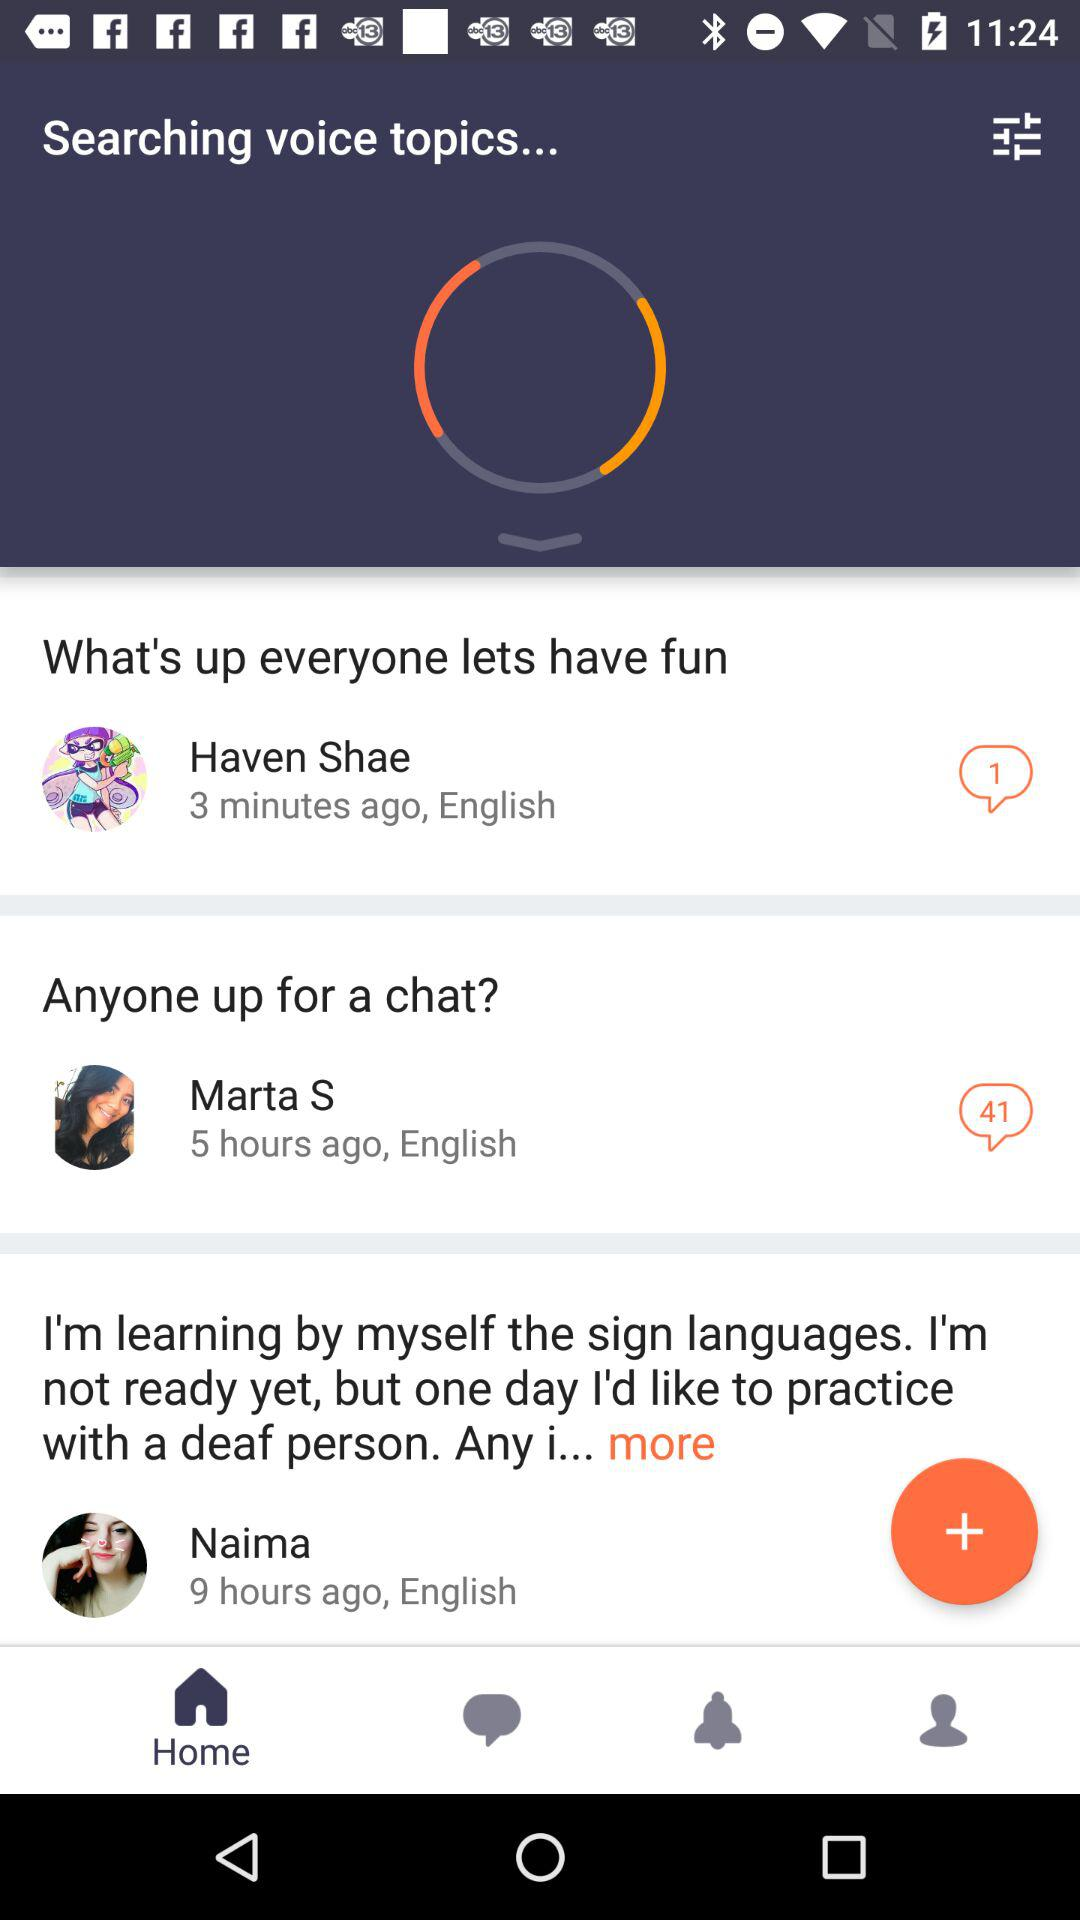What is the language of Marta S? The language of Marta S is English. 